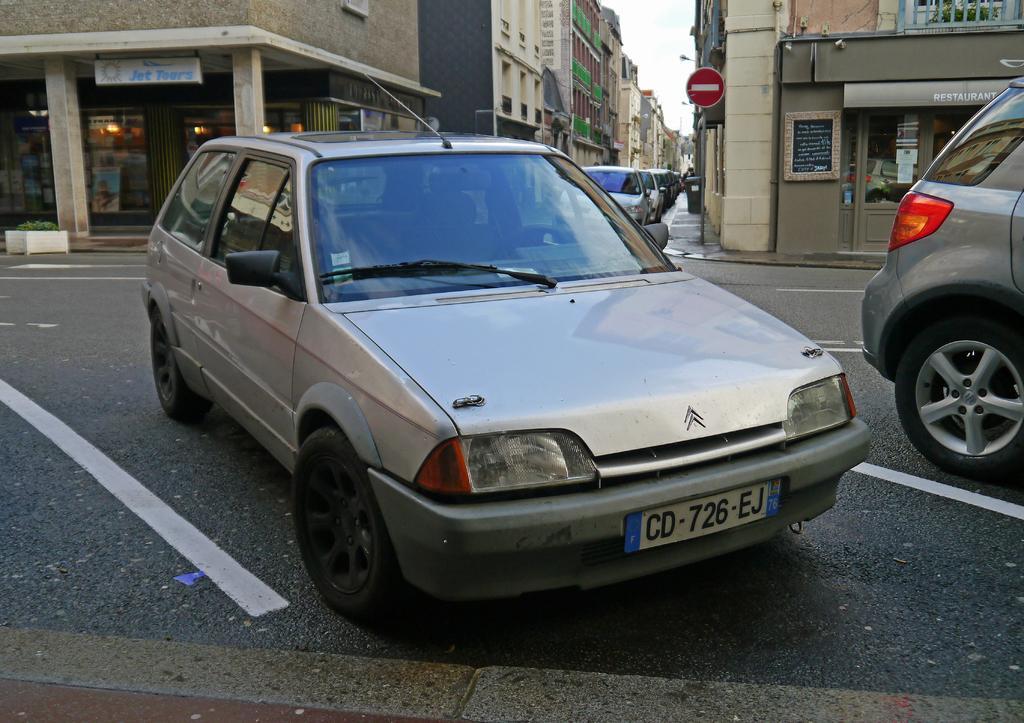Describe this image in one or two sentences. In this image I can see few vehicles on the road, in front the vehicle is in gray color. Background I can see a sign board in red color, few buildings in gray, cream and brown color, and the sky is in white color. 